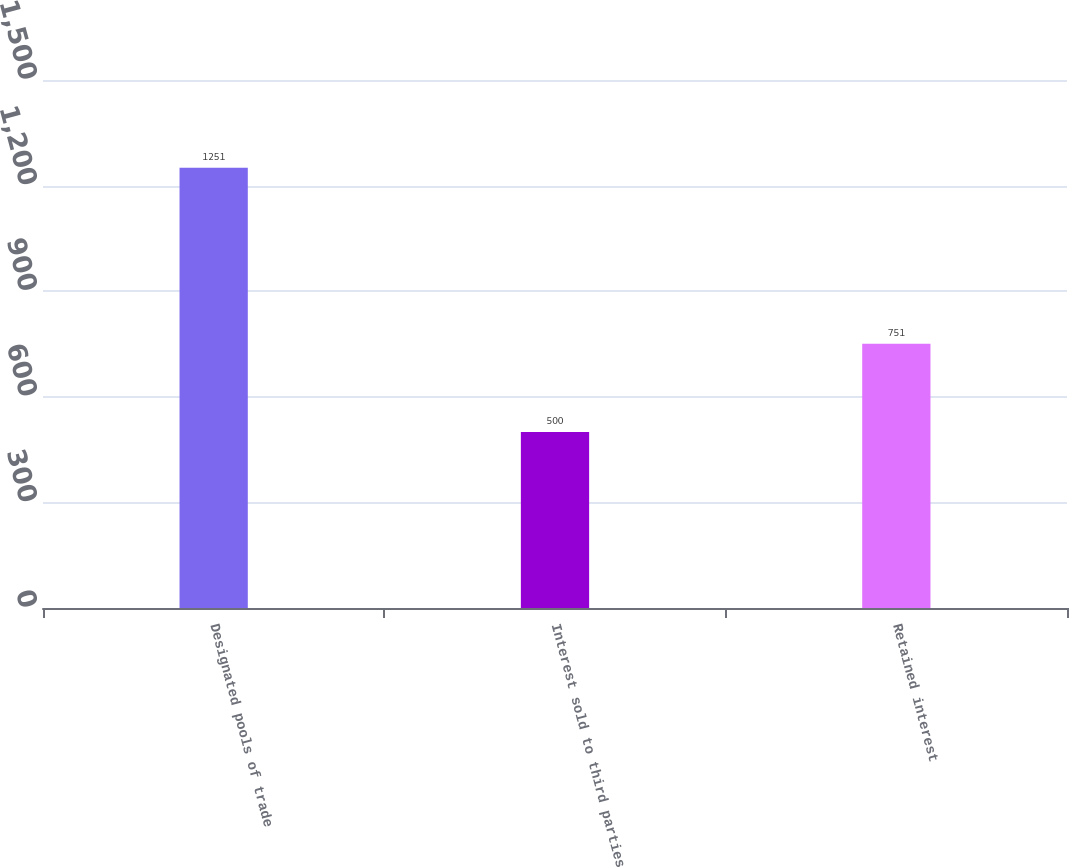Convert chart. <chart><loc_0><loc_0><loc_500><loc_500><bar_chart><fcel>Designated pools of trade<fcel>Interest sold to third parties<fcel>Retained interest<nl><fcel>1251<fcel>500<fcel>751<nl></chart> 